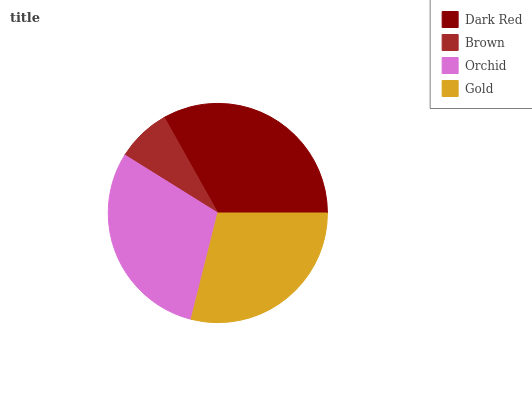Is Brown the minimum?
Answer yes or no. Yes. Is Dark Red the maximum?
Answer yes or no. Yes. Is Orchid the minimum?
Answer yes or no. No. Is Orchid the maximum?
Answer yes or no. No. Is Orchid greater than Brown?
Answer yes or no. Yes. Is Brown less than Orchid?
Answer yes or no. Yes. Is Brown greater than Orchid?
Answer yes or no. No. Is Orchid less than Brown?
Answer yes or no. No. Is Orchid the high median?
Answer yes or no. Yes. Is Gold the low median?
Answer yes or no. Yes. Is Brown the high median?
Answer yes or no. No. Is Orchid the low median?
Answer yes or no. No. 